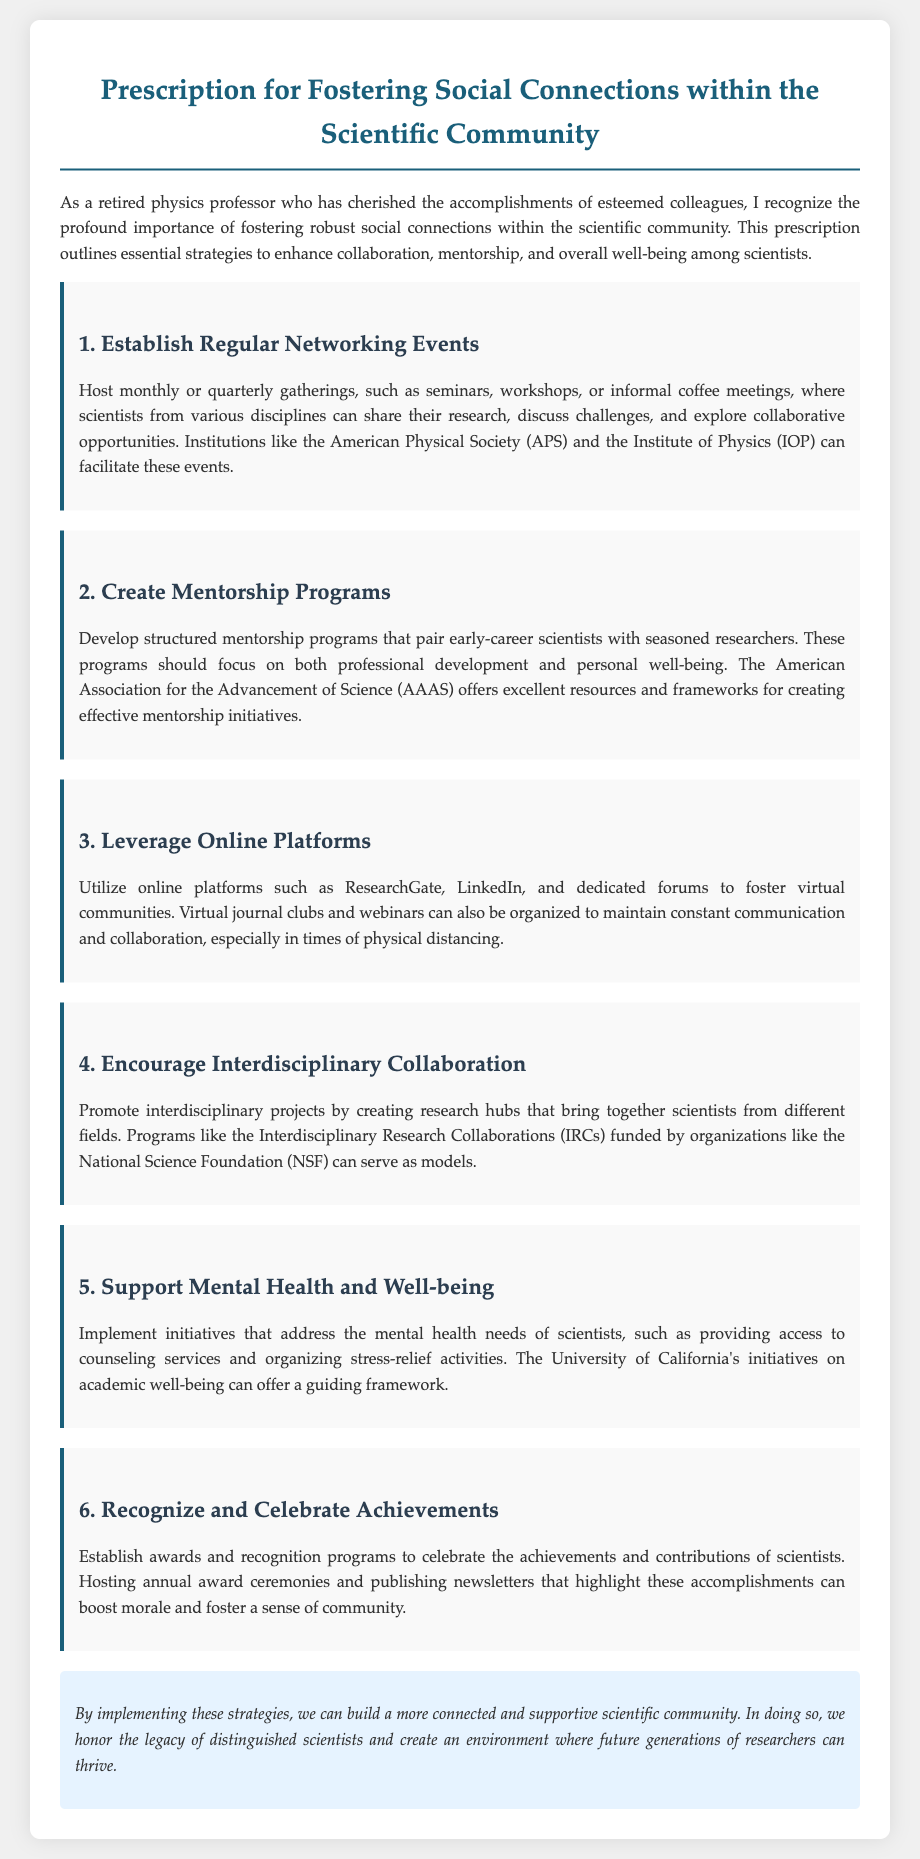What is the title of the document? The title appears prominently at the top of the document, which outlines the main theme of the content.
Answer: Prescription for Fostering Social Connections within the Scientific Community How many main sections are in the document? Each section is distinctly titled, and counting these reveals the structure of the document.
Answer: 6 Name one organization mentioned that can facilitate networking events. The document lists organizations that support networking, helping to establish connections within the scientific community.
Answer: American Physical Society What is one way to support mental health mentioned in the document? The document outlines specific initiatives to support scientists' mental health, focusing on their well-being.
Answer: Counseling services What is the primary goal of this prescription? The document clearly articulates its intention to enhance collaboration and community within the scientific field.
Answer: Foster social connections What type of events does the prescription suggest for networking? The document recommends specific formats for gatherings that would help scientists connect and share.
Answer: Seminars, workshops, or informal coffee meetings 